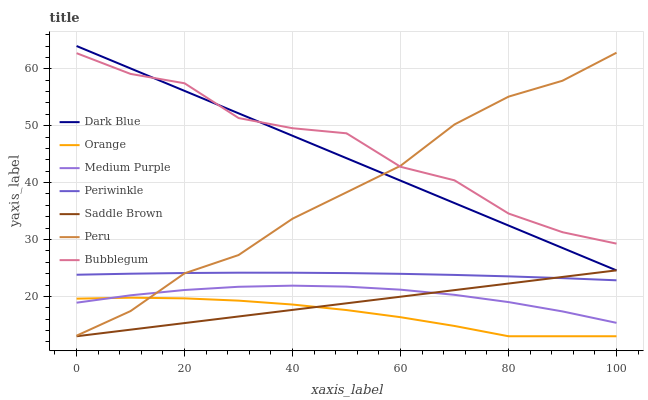Does Orange have the minimum area under the curve?
Answer yes or no. Yes. Does Bubblegum have the maximum area under the curve?
Answer yes or no. Yes. Does Medium Purple have the minimum area under the curve?
Answer yes or no. No. Does Medium Purple have the maximum area under the curve?
Answer yes or no. No. Is Saddle Brown the smoothest?
Answer yes or no. Yes. Is Bubblegum the roughest?
Answer yes or no. Yes. Is Medium Purple the smoothest?
Answer yes or no. No. Is Medium Purple the roughest?
Answer yes or no. No. Does Orange have the lowest value?
Answer yes or no. Yes. Does Medium Purple have the lowest value?
Answer yes or no. No. Does Dark Blue have the highest value?
Answer yes or no. Yes. Does Medium Purple have the highest value?
Answer yes or no. No. Is Orange less than Periwinkle?
Answer yes or no. Yes. Is Bubblegum greater than Orange?
Answer yes or no. Yes. Does Orange intersect Medium Purple?
Answer yes or no. Yes. Is Orange less than Medium Purple?
Answer yes or no. No. Is Orange greater than Medium Purple?
Answer yes or no. No. Does Orange intersect Periwinkle?
Answer yes or no. No. 